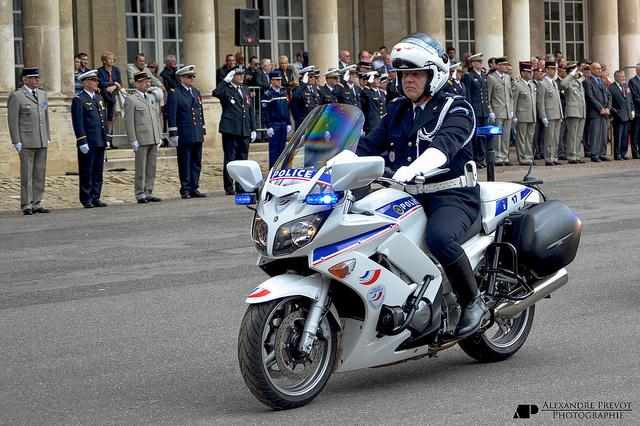Who pays this man's salary? Please explain your reasoning. government. The man is riding a police motorcycle and is wearing a uniform, so he is a cop. police officers are not employed by private or religious organizations. 